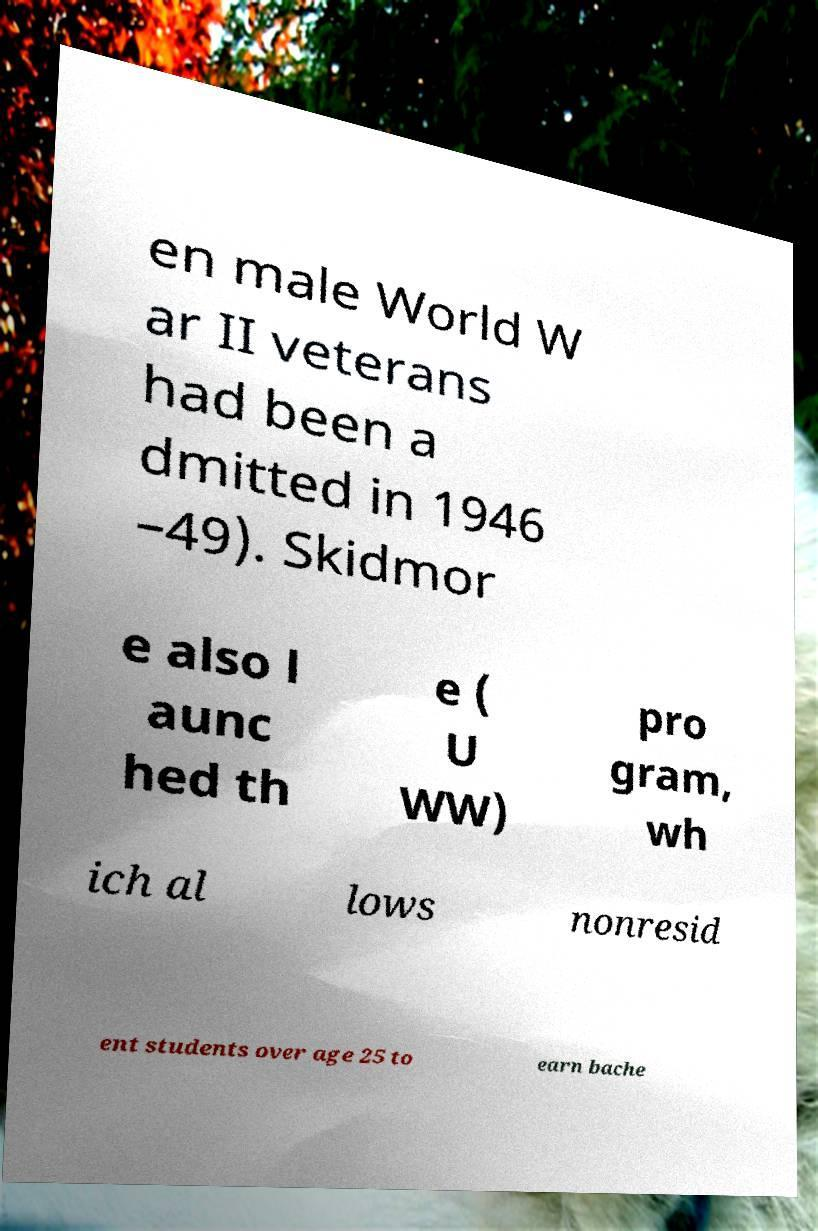Could you assist in decoding the text presented in this image and type it out clearly? en male World W ar II veterans had been a dmitted in 1946 –49). Skidmor e also l aunc hed th e ( U WW) pro gram, wh ich al lows nonresid ent students over age 25 to earn bache 